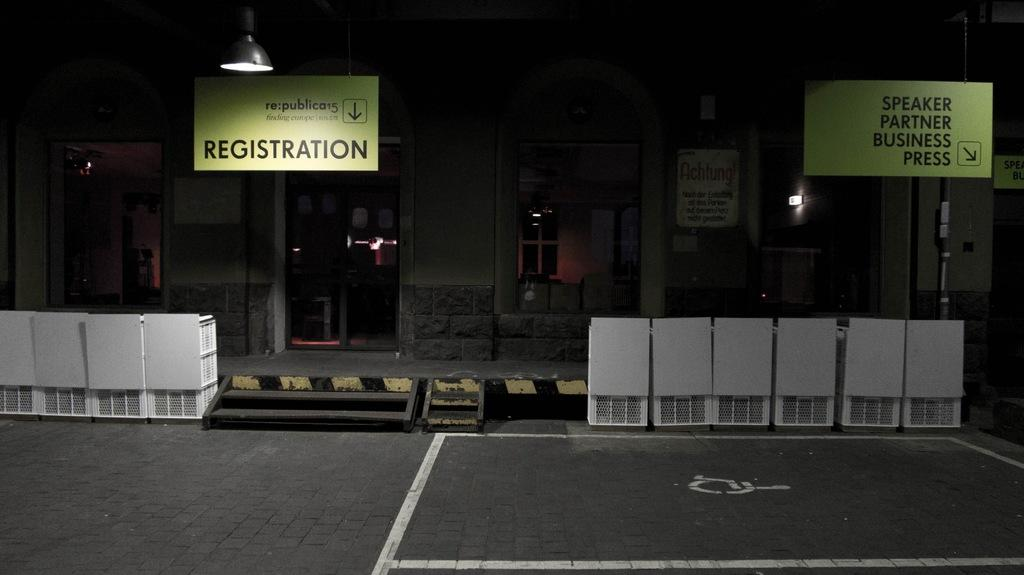What type of structure is visible in the image? There is a building in the image. What feature of the building is mentioned in the facts? The building has doors. What other objects can be seen in the image? There are boards, lights, a road, stairs, and some objects present in the image. What type of flag is being waved by the person in the image? There is no person or flag present in the image. How can the objects in the image be joined together? The objects in the image are not being joined together; they are separate entities. 